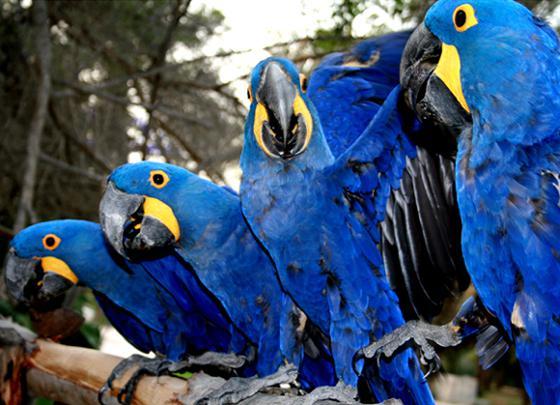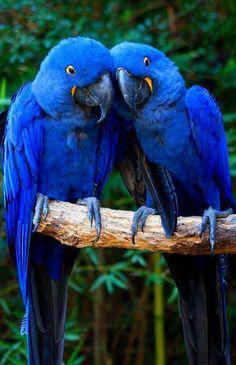The first image is the image on the left, the second image is the image on the right. For the images shown, is this caption "Two birds sit on a branch in the image on the right." true? Answer yes or no. Yes. The first image is the image on the left, the second image is the image on the right. For the images displayed, is the sentence "An image includes blue parrots with bright yellow chests." factually correct? Answer yes or no. No. 